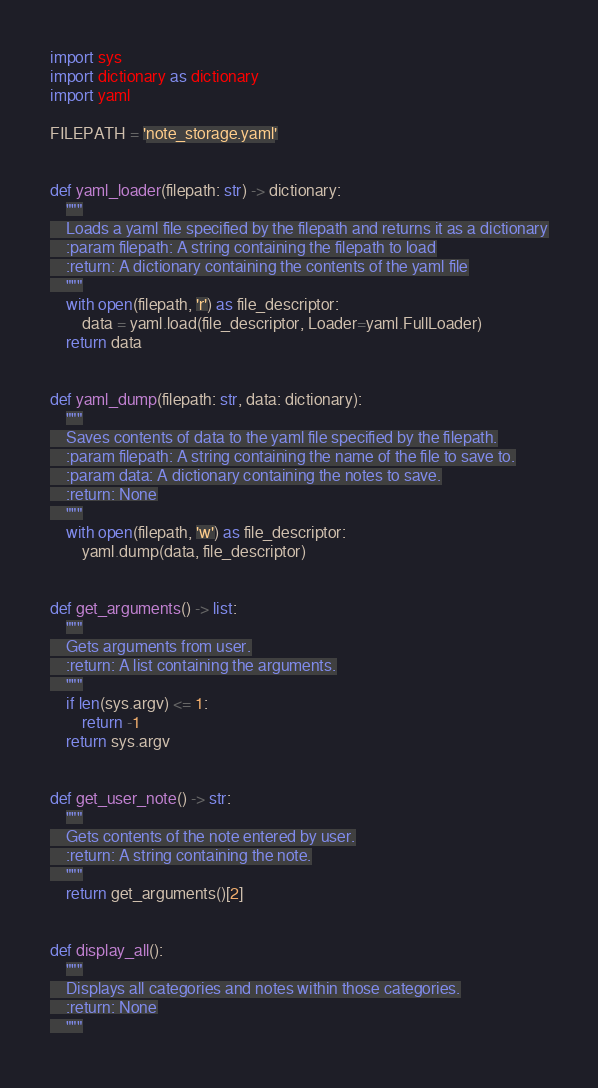Convert code to text. <code><loc_0><loc_0><loc_500><loc_500><_Python_>import sys
import dictionary as dictionary
import yaml

FILEPATH = 'note_storage.yaml'


def yaml_loader(filepath: str) -> dictionary:
    """
    Loads a yaml file specified by the filepath and returns it as a dictionary
    :param filepath: A string containing the filepath to load
    :return: A dictionary containing the contents of the yaml file
    """
    with open(filepath, 'r') as file_descriptor:
        data = yaml.load(file_descriptor, Loader=yaml.FullLoader)
    return data


def yaml_dump(filepath: str, data: dictionary):
    """
    Saves contents of data to the yaml file specified by the filepath.
    :param filepath: A string containing the name of the file to save to.
    :param data: A dictionary containing the notes to save.
    :return: None
    """
    with open(filepath, 'w') as file_descriptor:
        yaml.dump(data, file_descriptor)


def get_arguments() -> list:
    """
    Gets arguments from user.
    :return: A list containing the arguments.
    """
    if len(sys.argv) <= 1:
        return -1
    return sys.argv


def get_user_note() -> str:
    """
    Gets contents of the note entered by user.
    :return: A string containing the note.
    """
    return get_arguments()[2]


def display_all():
    """
    Displays all categories and notes within those categories.
    :return: None
    """</code> 